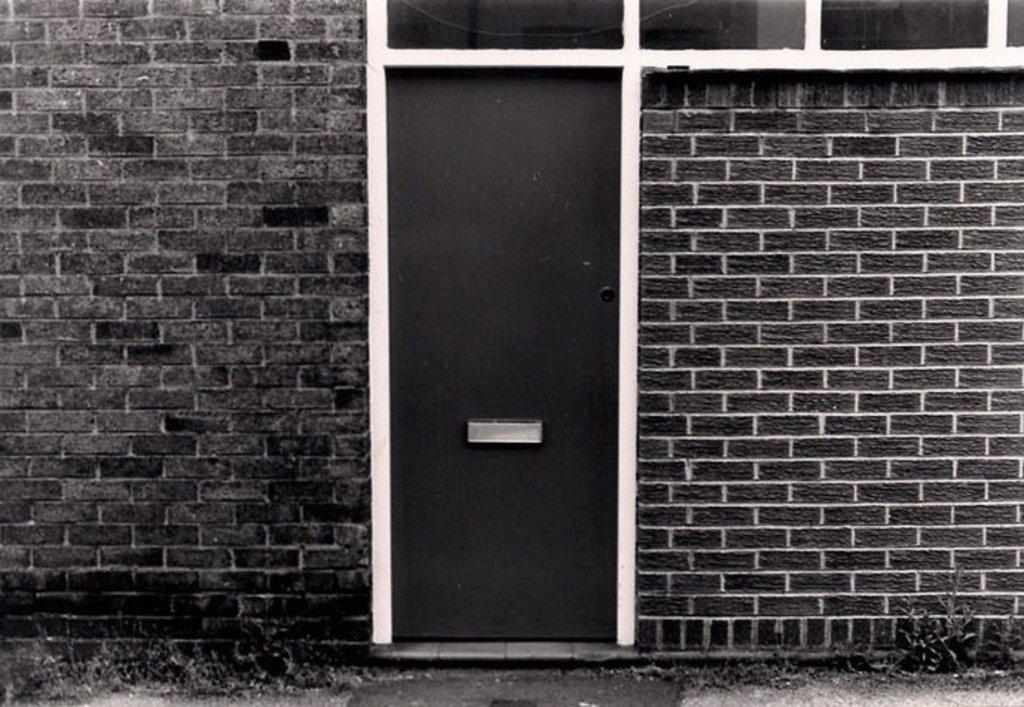Describe this image in one or two sentences. In the picture we can see a house wall with bricks and in the middle of it, we can see a door which is black in color. 